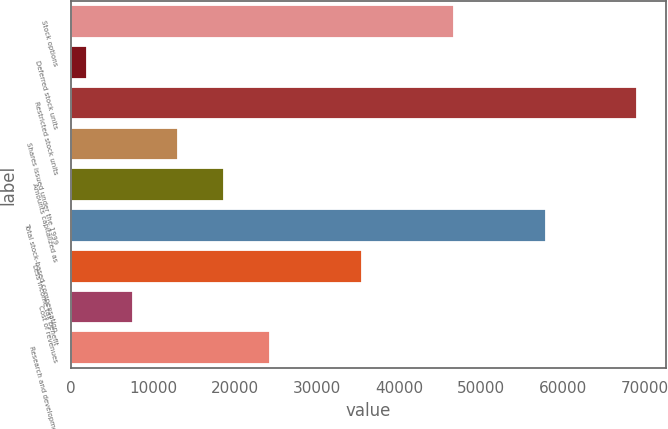Convert chart to OTSL. <chart><loc_0><loc_0><loc_500><loc_500><bar_chart><fcel>Stock options<fcel>Deferred stock units<fcel>Restricted stock units<fcel>Shares issued under the 1999<fcel>Amounts capitalized as<fcel>Total stock-based compensation<fcel>Less Income tax benefit<fcel>Cost of revenues<fcel>Research and development<nl><fcel>46696.2<fcel>1885<fcel>69101.8<fcel>13087.8<fcel>18689.2<fcel>57899<fcel>35493.4<fcel>7486.4<fcel>24290.6<nl></chart> 